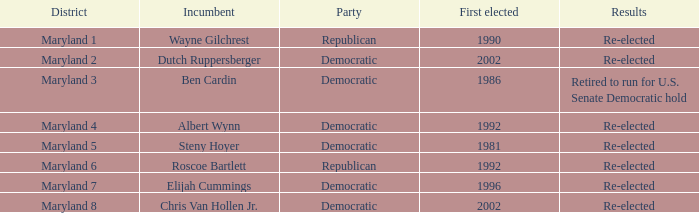Who is the incumbent who was first elected before 2002 from the maryland 3 district? Ben Cardin. 